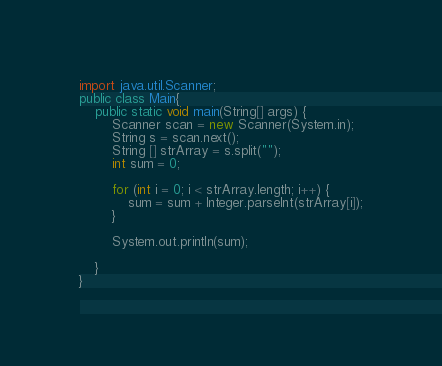<code> <loc_0><loc_0><loc_500><loc_500><_Java_>import java.util.Scanner;
public class Main{
    public static void main(String[] args) {
        Scanner scan = new Scanner(System.in);
        String s = scan.next();
        String [] strArray = s.split("");
        int sum = 0;

        for (int i = 0; i < strArray.length; i++) {
            sum = sum + Integer.parseInt(strArray[i]);
        }
        
        System.out.println(sum);

    }
}</code> 